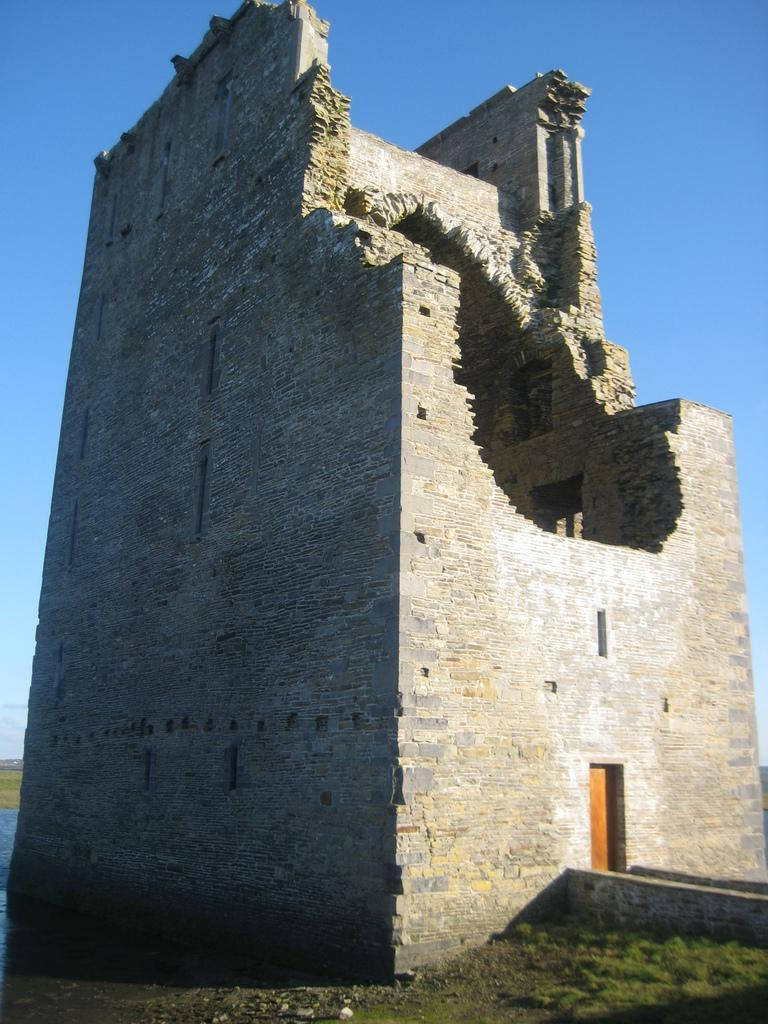What structure is the main subject of the picture? There is a fort in the picture. Are there any noticeable damages to the fort? Yes, there is a broken wall in the fort. Where is the entrance to the fort located? There is a door at the right bottom of the fort. What type of vegetation can be seen on the wall? There is grass on the wall. What is the condition of the sky in the picture? The sky is clear in the picture. Can you tell me how many parcels are being delivered to the fort in the image? There is no mention of parcels or delivery in the image; it only shows a fort with a broken wall and a door. Are there any slaves depicted in the image? There is no mention of slaves or any human figures in the image; it only shows a fort with a broken wall and a door. 